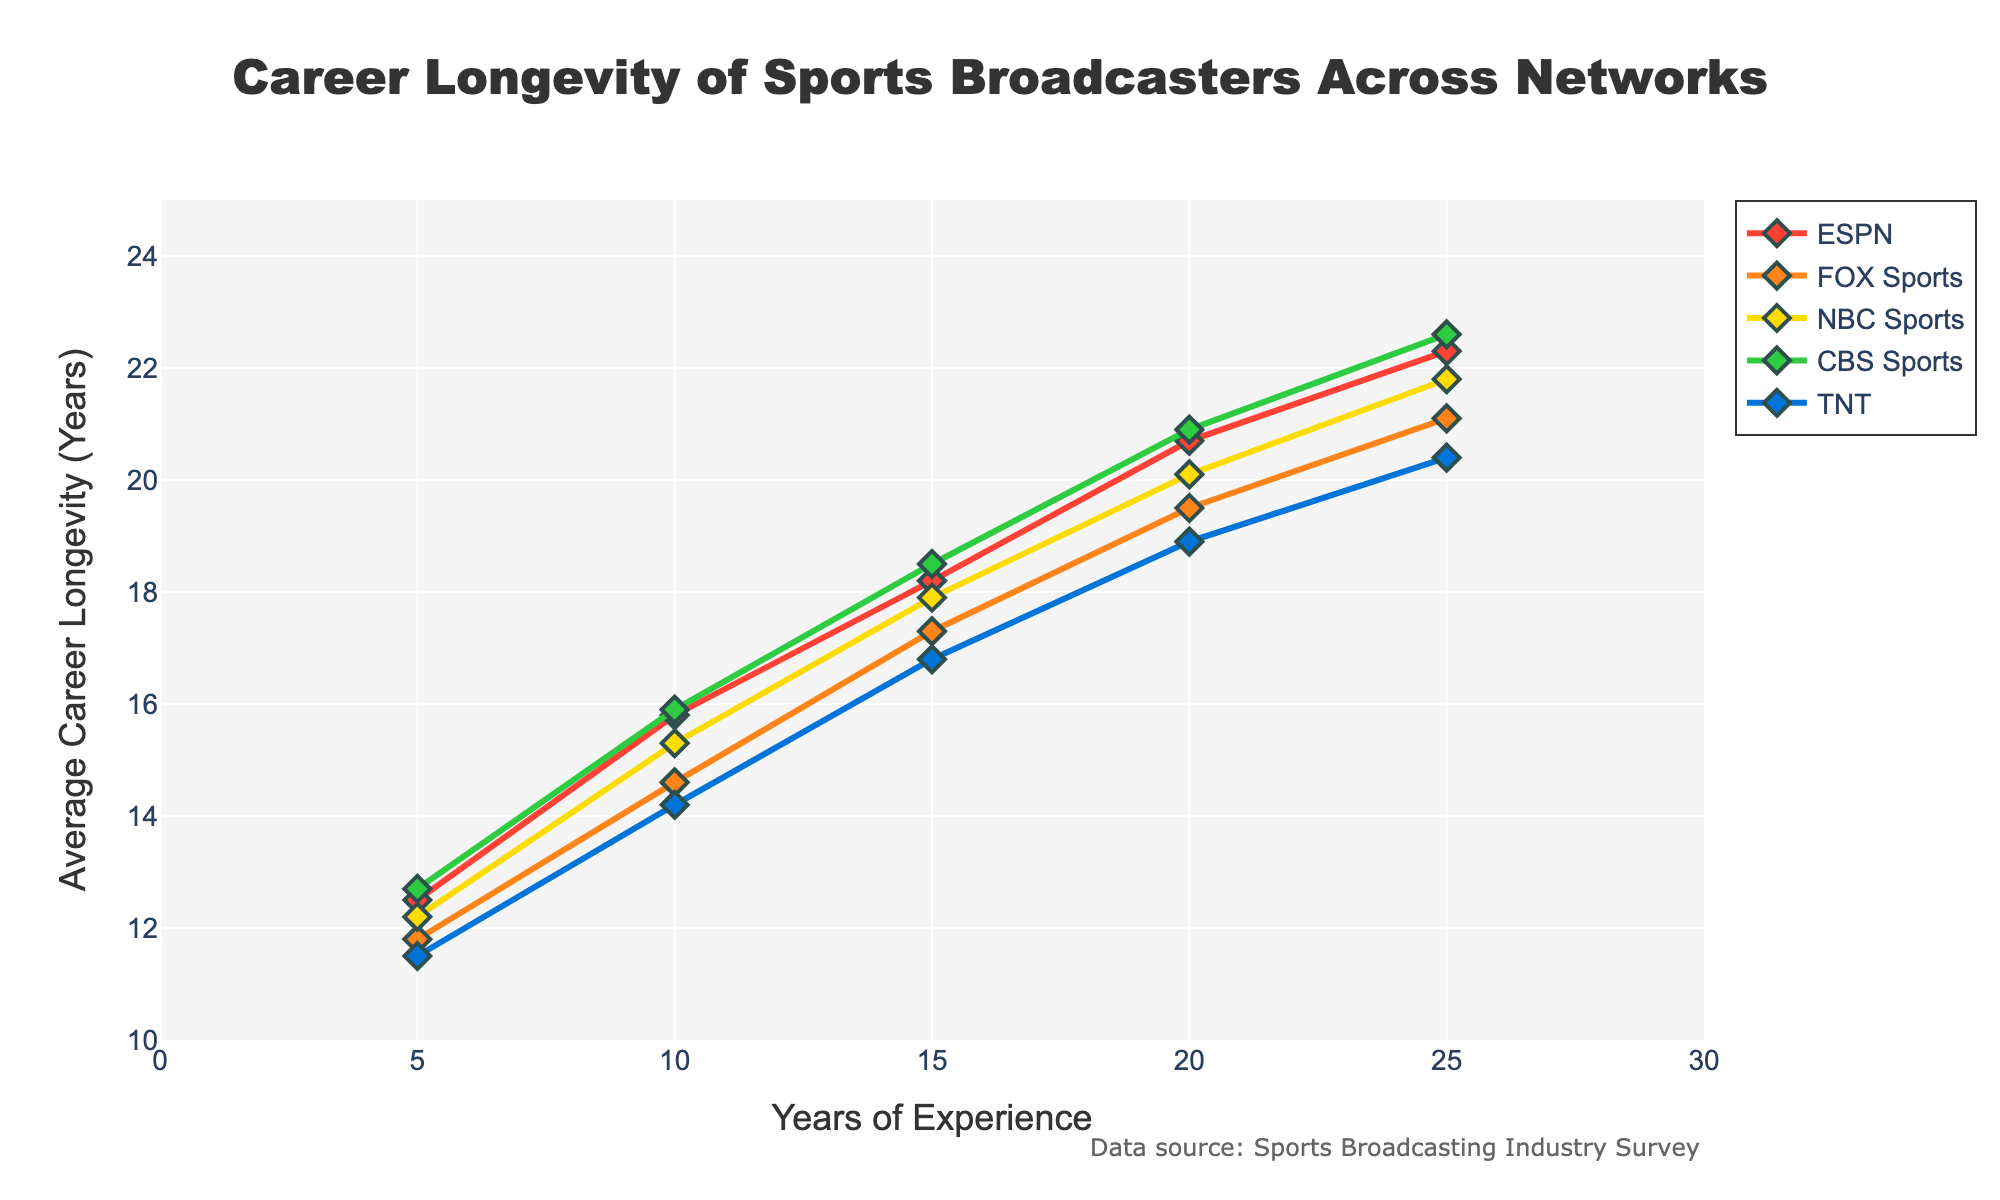What network shows the highest average career longevity for broadcasters with 15 years of experience? Look at the data points corresponding to 15 years of experience for each network. Compare the y-values: ESPN (18.2), FOX Sports (17.3), NBC Sports (17.9), CBS Sports (18.5), and TNT (16.8). CBS Sports has the highest value.
Answer: CBS Sports Which network has the most rapid increase in average career longevity from 5 to 10 years of experience? Calculate the difference in average career longevity between 5 and 10 years for each network: ESPN (15.8 - 12.5 = 3.3), FOX Sports (14.6 - 11.8 = 2.8), NBC Sports (15.3 - 12.2 = 3.1), CBS Sports (15.9 - 12.7 = 3.2), and TNT (14.2 - 11.5 = 2.7). ESPN has the highest increase.
Answer: ESPN What is the range of average career longevity for broadcasters with 20 years of experience across all networks? Find the minimum and maximum values for the 20 years of experience data points: ESPN (20.7), FOX Sports (19.5), NBC Sports (20.1), CBS Sports (20.9), TNT (18.9). The range is maximum - minimum: 20.9 - 18.9 = 2.0.
Answer: 2.0 Which network has the least consistent growth in average career longevity over time? Visually inspect the smoothness and uniformity of growth rates. TNT has the least consistent growth because it appears less smooth with a more varied slope compared to others.
Answer: TNT By how much does ESPN's average career longevity increase from 5 to 25 years of experience? Calculate the difference between the average career longevity at 25 years and 5 years for ESPN: 22.3 - 12.5 = 9.8.
Answer: 9.8 Which network has the smallest increase in average career longevity between 20 to 25 years of experience? Calculate the difference for each network: ESPN (22.3 - 20.7 = 1.6), FOX Sports (21.1 - 19.5 = 1.6), NBC Sports (21.8 - 20.1 = 1.7), CBS Sports (22.6 - 20.9 = 1.7), TNT (20.4 - 18.9 = 1.5). TNT has the smallest increase.
Answer: TNT At 25 years of experience, which two networks have the closest average career longevity values? Compare the y-values for the 25 years of experience data points and find the closest pair: ESPN (22.3), FOX Sports (21.1), NBC Sports (21.8), CBS Sports (22.6), TNT (20.4). The closest values are between ESPN (22.3) and CBS Sports (22.6) with a difference of 0.3.
Answer: ESPN and CBS Sports What is the average career longevity for broadcasters with 10 years of experience across all networks? Sum the average career longevity for 10 years of experience and divide by the number of networks: (15.8 + 14.6 + 15.3 + 15.9 + 14.2) / 5 = 75.8 / 5 = 15.16.
Answer: 15.16 